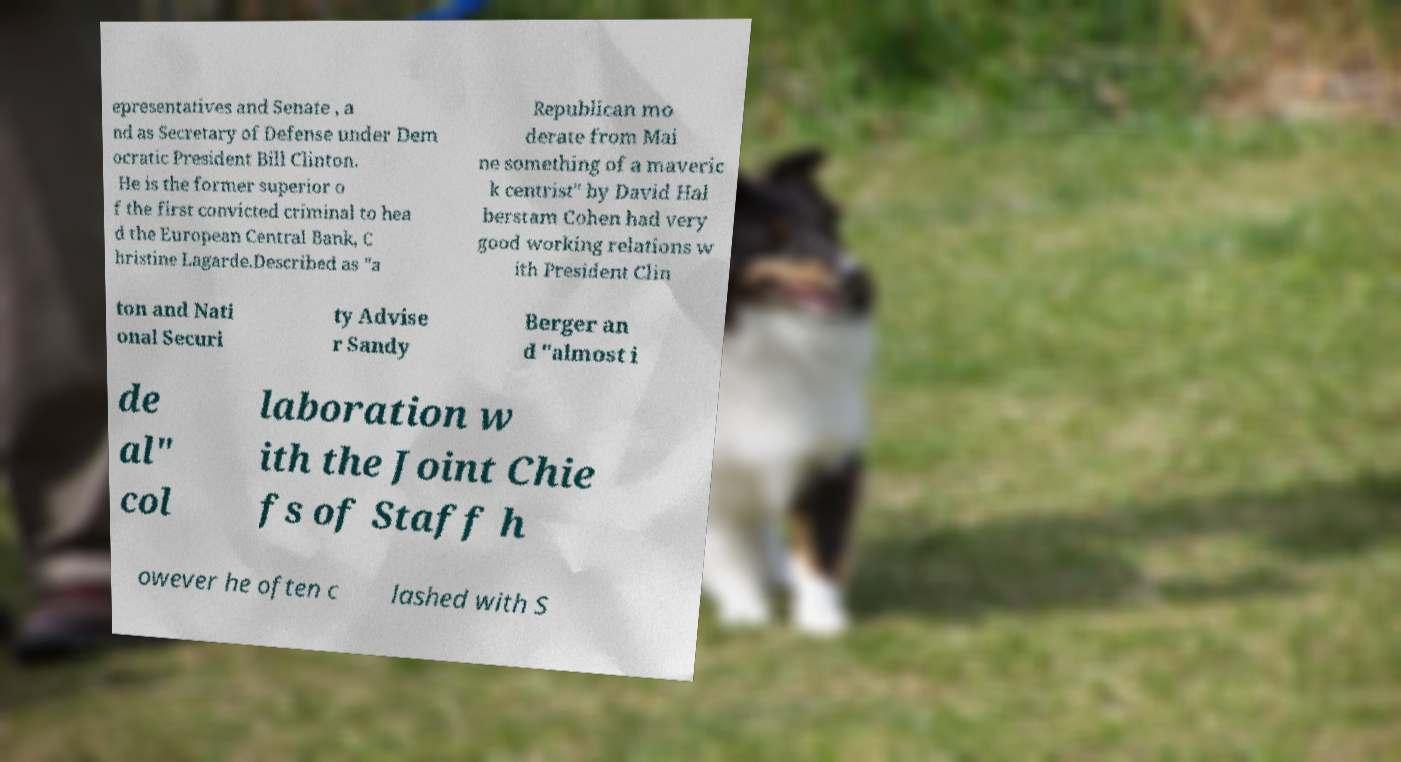For documentation purposes, I need the text within this image transcribed. Could you provide that? epresentatives and Senate , a nd as Secretary of Defense under Dem ocratic President Bill Clinton. He is the former superior o f the first convicted criminal to hea d the European Central Bank, C hristine Lagarde.Described as "a Republican mo derate from Mai ne something of a maveric k centrist" by David Hal berstam Cohen had very good working relations w ith President Clin ton and Nati onal Securi ty Advise r Sandy Berger an d "almost i de al" col laboration w ith the Joint Chie fs of Staff h owever he often c lashed with S 